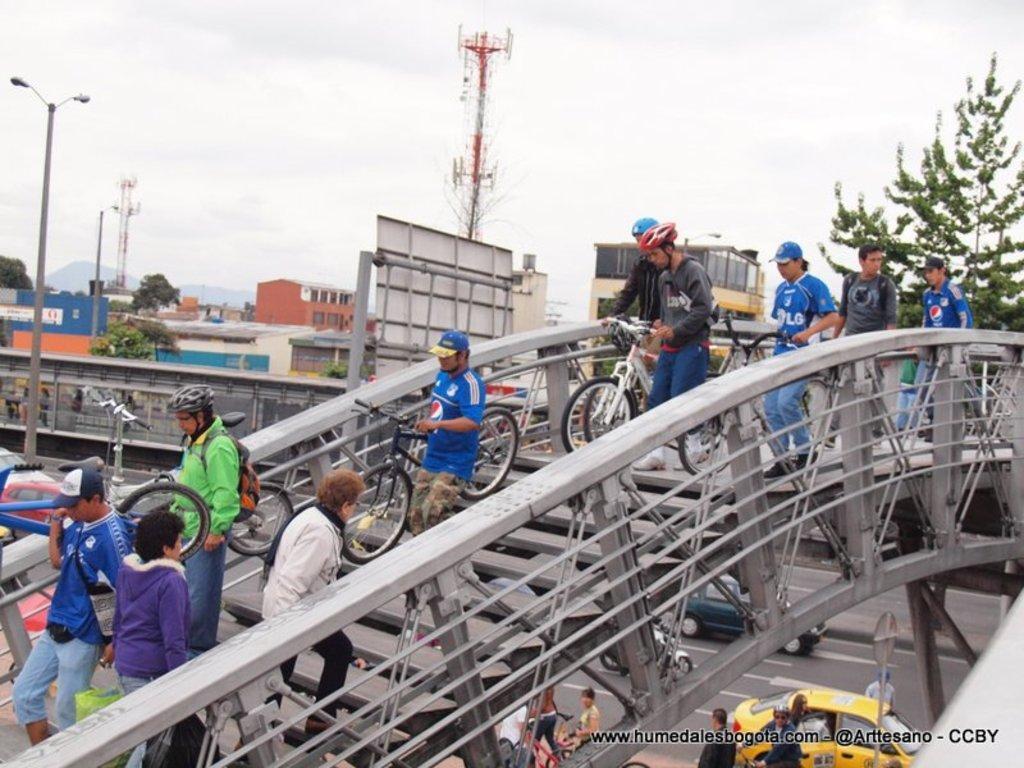Describe this image in one or two sentences. In this image there are group of people holding bicycles and walking on the stair case, and at the background there are vehicles on the road, lights, poles, buildings, trees,hills, sky. 